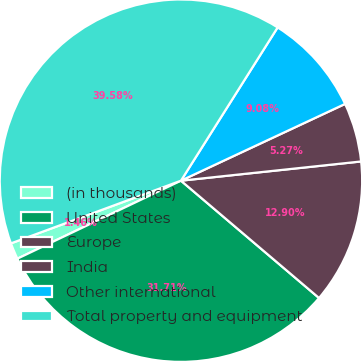Convert chart. <chart><loc_0><loc_0><loc_500><loc_500><pie_chart><fcel>(in thousands)<fcel>United States<fcel>Europe<fcel>India<fcel>Other international<fcel>Total property and equipment<nl><fcel>1.46%<fcel>31.71%<fcel>12.9%<fcel>5.27%<fcel>9.08%<fcel>39.58%<nl></chart> 